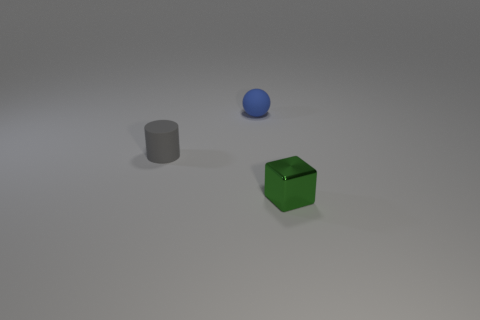Add 1 small brown spheres. How many objects exist? 4 Subtract all spheres. How many objects are left? 2 Subtract all tiny gray cylinders. Subtract all gray things. How many objects are left? 1 Add 2 rubber things. How many rubber things are left? 4 Add 2 tiny green blocks. How many tiny green blocks exist? 3 Subtract 0 yellow spheres. How many objects are left? 3 